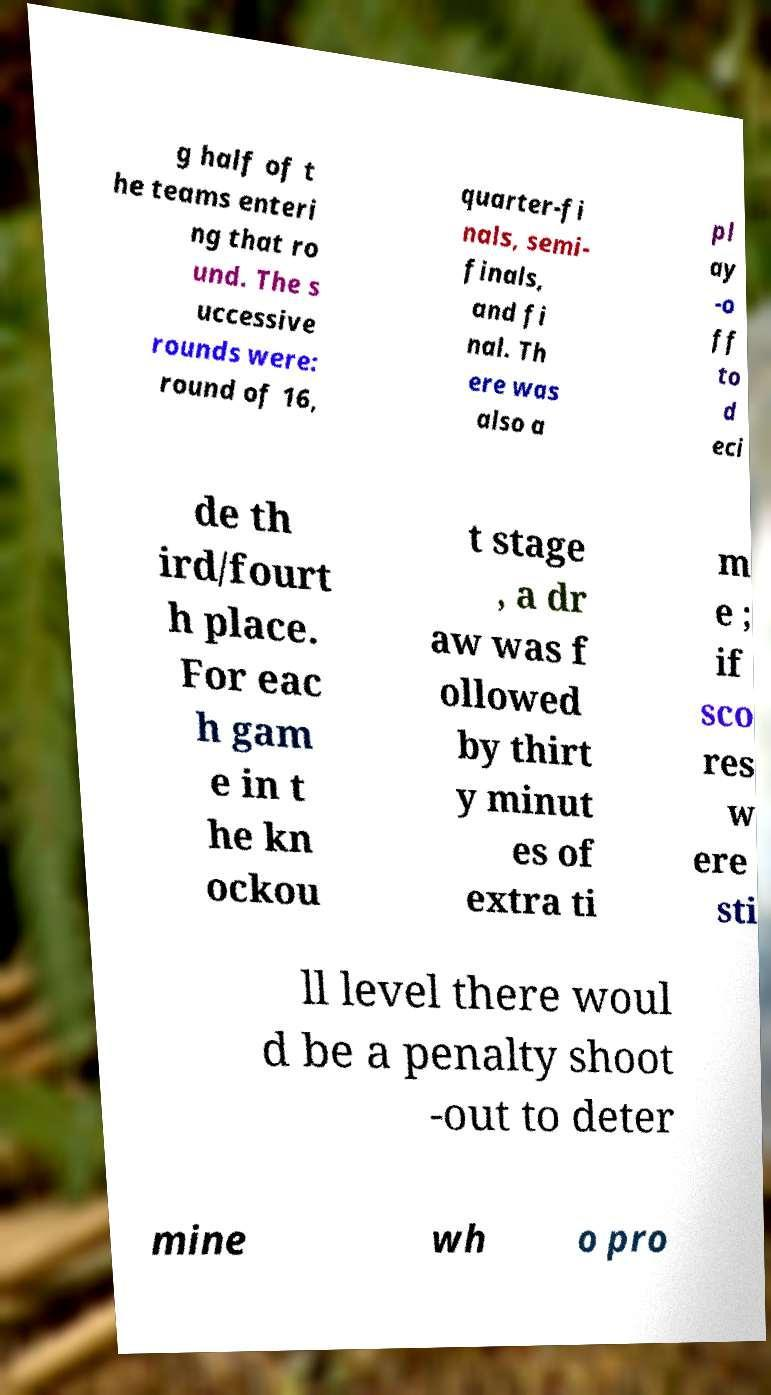There's text embedded in this image that I need extracted. Can you transcribe it verbatim? g half of t he teams enteri ng that ro und. The s uccessive rounds were: round of 16, quarter-fi nals, semi- finals, and fi nal. Th ere was also a pl ay -o ff to d eci de th ird/fourt h place. For eac h gam e in t he kn ockou t stage , a dr aw was f ollowed by thirt y minut es of extra ti m e ; if sco res w ere sti ll level there woul d be a penalty shoot -out to deter mine wh o pro 